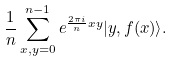Convert formula to latex. <formula><loc_0><loc_0><loc_500><loc_500>\frac { 1 } { n } \sum _ { x , y = 0 } ^ { n - 1 } e ^ { \frac { 2 \pi i } n x y } | y , f ( x ) \rangle .</formula> 